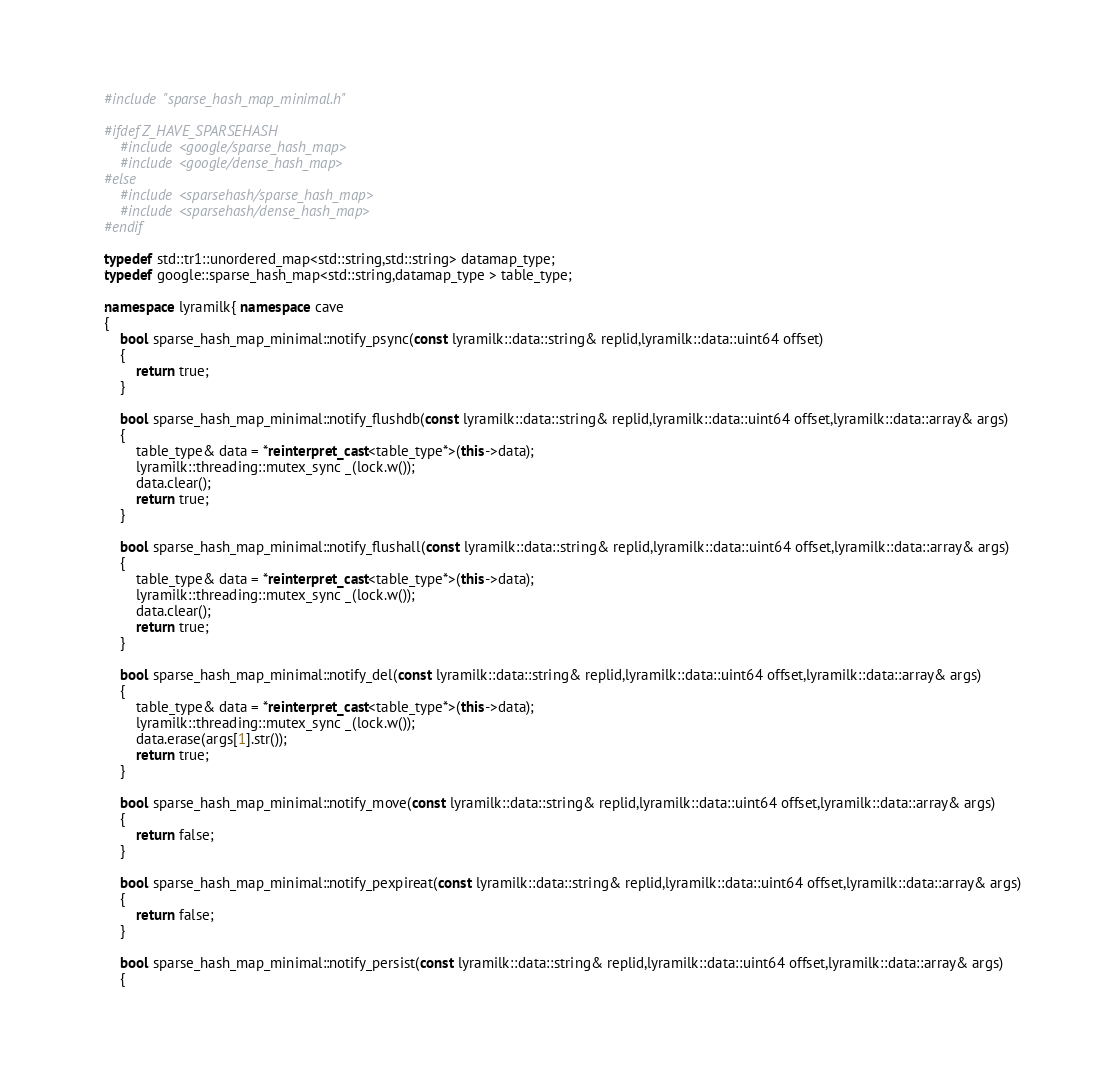Convert code to text. <code><loc_0><loc_0><loc_500><loc_500><_C++_>#include "sparse_hash_map_minimal.h"

#ifdef Z_HAVE_SPARSEHASH
	#include <google/sparse_hash_map> 
	#include <google/dense_hash_map> 
#else
	#include <sparsehash/sparse_hash_map> 
	#include <sparsehash/dense_hash_map> 
#endif

typedef std::tr1::unordered_map<std::string,std::string> datamap_type;
typedef google::sparse_hash_map<std::string,datamap_type > table_type;

namespace lyramilk{ namespace cave
{
	bool sparse_hash_map_minimal::notify_psync(const lyramilk::data::string& replid,lyramilk::data::uint64 offset)
	{
		return true;
	}

	bool sparse_hash_map_minimal::notify_flushdb(const lyramilk::data::string& replid,lyramilk::data::uint64 offset,lyramilk::data::array& args)
	{
		table_type& data = *reinterpret_cast<table_type*>(this->data);
		lyramilk::threading::mutex_sync _(lock.w());
		data.clear();
		return true;
	}

	bool sparse_hash_map_minimal::notify_flushall(const lyramilk::data::string& replid,lyramilk::data::uint64 offset,lyramilk::data::array& args)
	{
		table_type& data = *reinterpret_cast<table_type*>(this->data);
		lyramilk::threading::mutex_sync _(lock.w());
		data.clear();
		return true;
	}

	bool sparse_hash_map_minimal::notify_del(const lyramilk::data::string& replid,lyramilk::data::uint64 offset,lyramilk::data::array& args)
	{
		table_type& data = *reinterpret_cast<table_type*>(this->data);
		lyramilk::threading::mutex_sync _(lock.w());
		data.erase(args[1].str());
		return true;
	}

	bool sparse_hash_map_minimal::notify_move(const lyramilk::data::string& replid,lyramilk::data::uint64 offset,lyramilk::data::array& args)
	{
		return false;
	}

	bool sparse_hash_map_minimal::notify_pexpireat(const lyramilk::data::string& replid,lyramilk::data::uint64 offset,lyramilk::data::array& args)
	{
		return false;
	}

	bool sparse_hash_map_minimal::notify_persist(const lyramilk::data::string& replid,lyramilk::data::uint64 offset,lyramilk::data::array& args)
	{</code> 